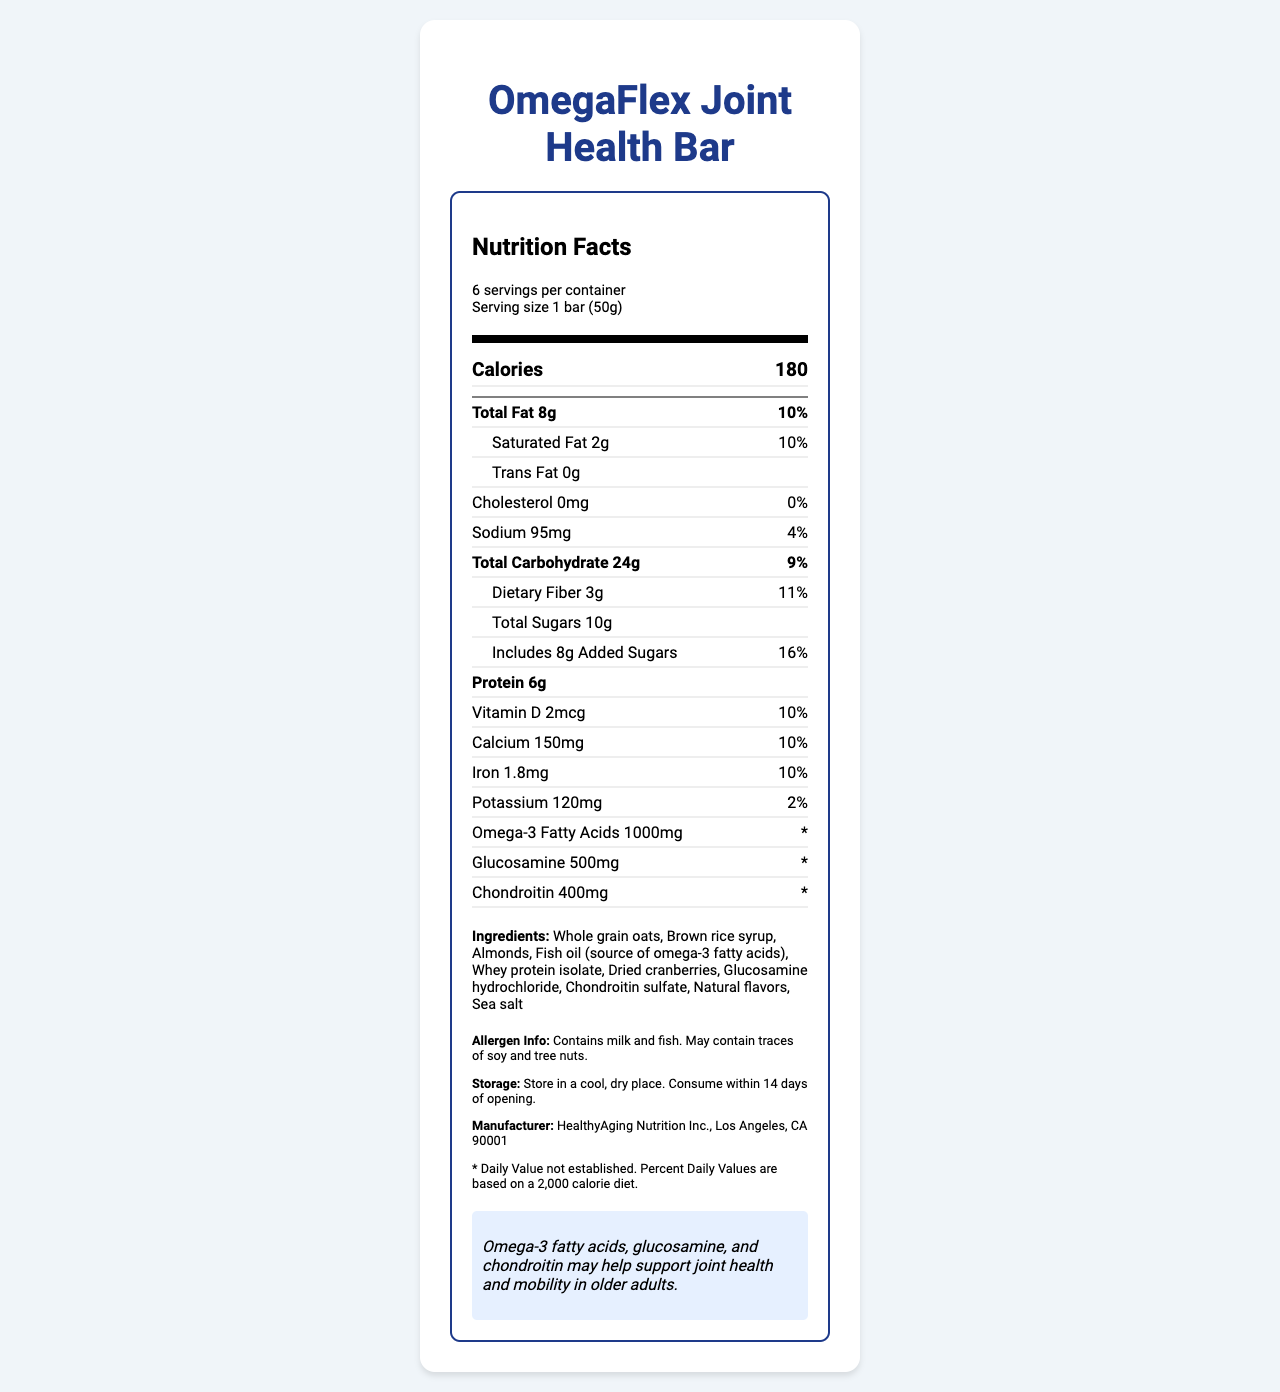what is the serving size for the OmegaFlex Joint Health Bar? According to the label, the serving size is listed as "1 bar (50g)."
Answer: 1 bar (50g) how many calories are in one serving? The nutrition facts state that each serving contains 180 calories.
Answer: 180 what percentage of the daily value is the total fat content? The label lists the total fat as 8g, which is 10% of the daily value.
Answer: 10% how much sodium is in each bar? The label specifies that one serving contains 95mg of sodium.
Answer: 95mg how much dietary fiber is in one bar? The nutritional information shows that each serving has 3g of dietary fiber.
Answer: 3g how much vitamin D does one serving provide? The label states that one bar contains 2mcg of vitamin D.
Answer: 2mcg what are the main ingredients in this product? A. Whole grain oats, almonds, and fish oil B. Whole grain oats, dried cranberries, and whey protein isolate C. Almonds, brown rice syrup, and sea salt D. Brown rice syrup, fish oil, and sea salt The label lists "Whole grain oats, Brown rice syrup, Almonds, Fish oil (source of omega-3 fatty acids)" as the first four ingredients.
Answer: A what is the primary health benefit promoted by this omega-3 fortified snack bar? A. Supports heart health B. Boosts energy levels C. Promotes joint health and mobility in older adults The health claim on the document states that the product "may help support joint health and mobility in older adults."
Answer: C does this product contain any tree nuts? The allergen information mentions that the product contains milk and fish and may contain traces of soy and tree nuts.
Answer: Yes summarize the key information presented on the OmegaFlex Joint Health Bar label. This summary encapsulates the essential nutritional information, ingredients, health claims, and allergen warnings provided on the OmegaFlex Joint Health Bar label.
Answer: The OmegaFlex Joint Health Bar is a snack bar designed to support joint health and mobility in older adults. Each serving (1 bar, 50g) contains 180 calories, 8g of total fat (10% DV), and significant levels of omega-3 fatty acids, glucosamine, and chondroitin. It also includes 3g of dietary fiber (11% DV), 10g of total sugars (including 8g of added sugars at 16% DV), and 6g of protein. The bar contains essential vitamins and minerals such as vitamin D, calcium, iron, and potassium. Key ingredients include whole grain oats, almonds, fish oil, and whey protein isolate, with allergen information noting the presence of milk and fish and possible traces of soy and tree nuts. It should be stored in a cool, dry place and consumed within 14 days of opening. how much glucosamine is in one serving? The label indicates that each bar contains 500mg of glucosamine.
Answer: 500mg does the OmegaFlex Joint Health Bar contain any cholesterols? The label states that the cholesterol content is 0mg.
Answer: No what type of fish oil is included in the ingredients? The label specifies that one of the ingredients is "Fish oil (source of omega-3 fatty acids)."
Answer: Fish oil (source of omega-3 fatty acids) what is the daily value for omega-3 fatty acids indicated on the label? The label notes that the daily value for omega-3 fatty acids is not established, indicated by '*'.
Answer: * is this product suitable for someone with a soy allergy? The allergen info states that the product "May contain traces of soy." Therefore, it may not be suitable for someone with a soy allergy.
Answer: Maybe what are the storage instructions for this product? The label provides clear storage instructions to ensure the product remains fresh.
Answer: Store in a cool, dry place. Consume within 14 days of opening. 